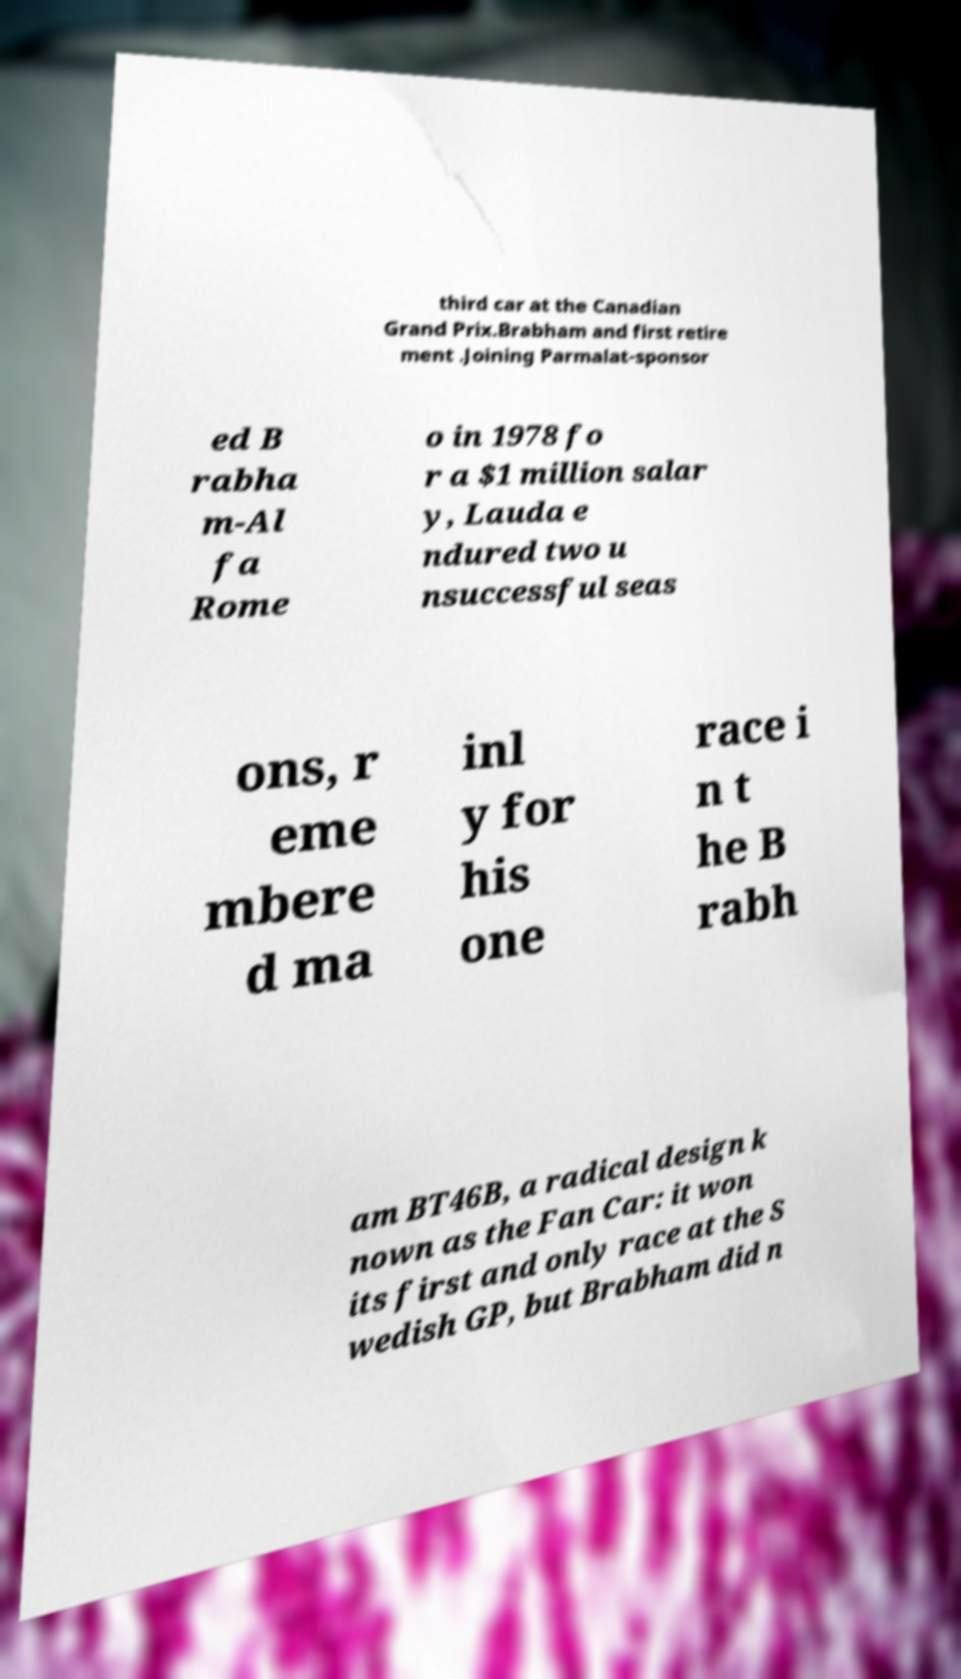Please read and relay the text visible in this image. What does it say? third car at the Canadian Grand Prix.Brabham and first retire ment .Joining Parmalat-sponsor ed B rabha m-Al fa Rome o in 1978 fo r a $1 million salar y, Lauda e ndured two u nsuccessful seas ons, r eme mbere d ma inl y for his one race i n t he B rabh am BT46B, a radical design k nown as the Fan Car: it won its first and only race at the S wedish GP, but Brabham did n 